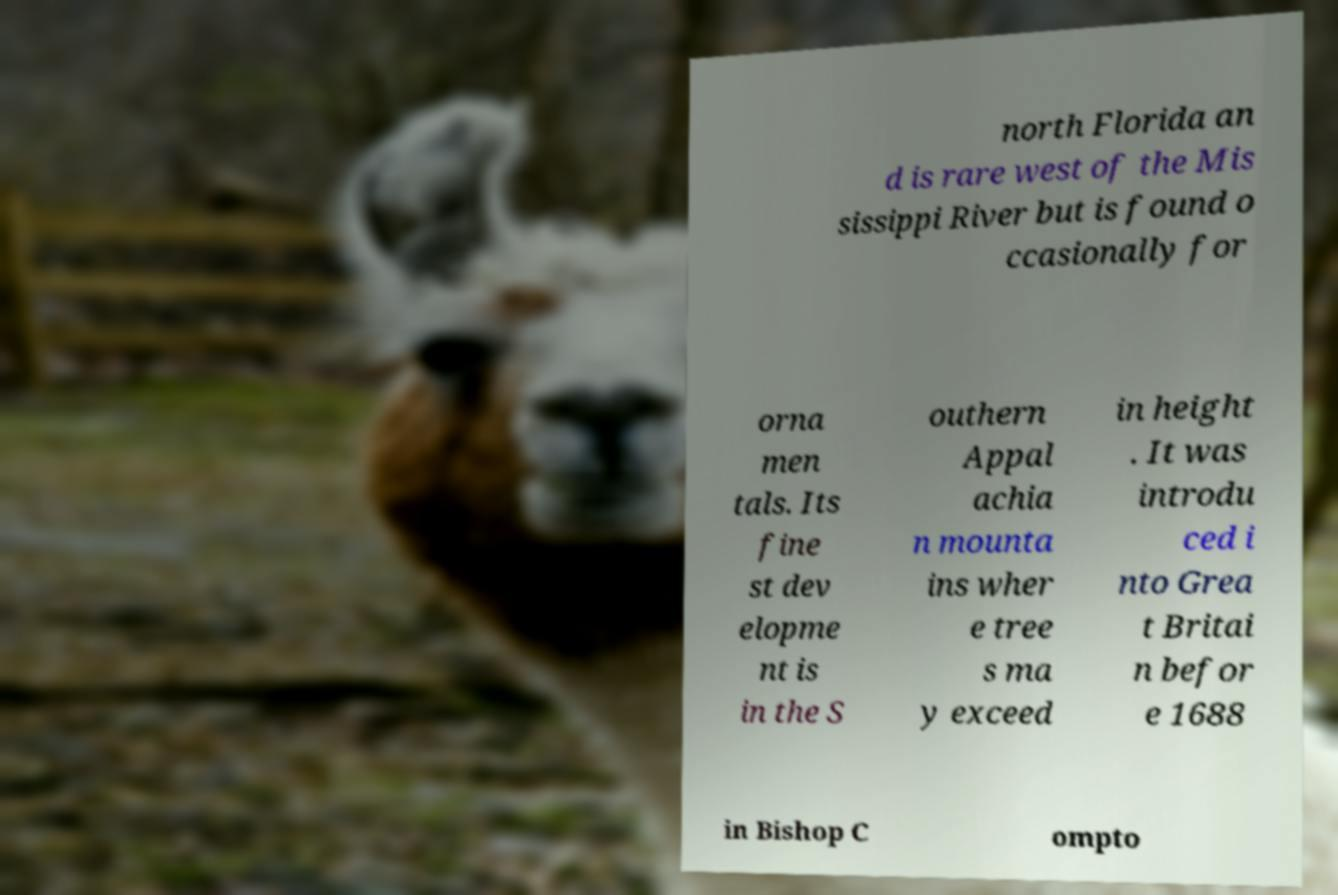Can you read and provide the text displayed in the image?This photo seems to have some interesting text. Can you extract and type it out for me? north Florida an d is rare west of the Mis sissippi River but is found o ccasionally for orna men tals. Its fine st dev elopme nt is in the S outhern Appal achia n mounta ins wher e tree s ma y exceed in height . It was introdu ced i nto Grea t Britai n befor e 1688 in Bishop C ompto 